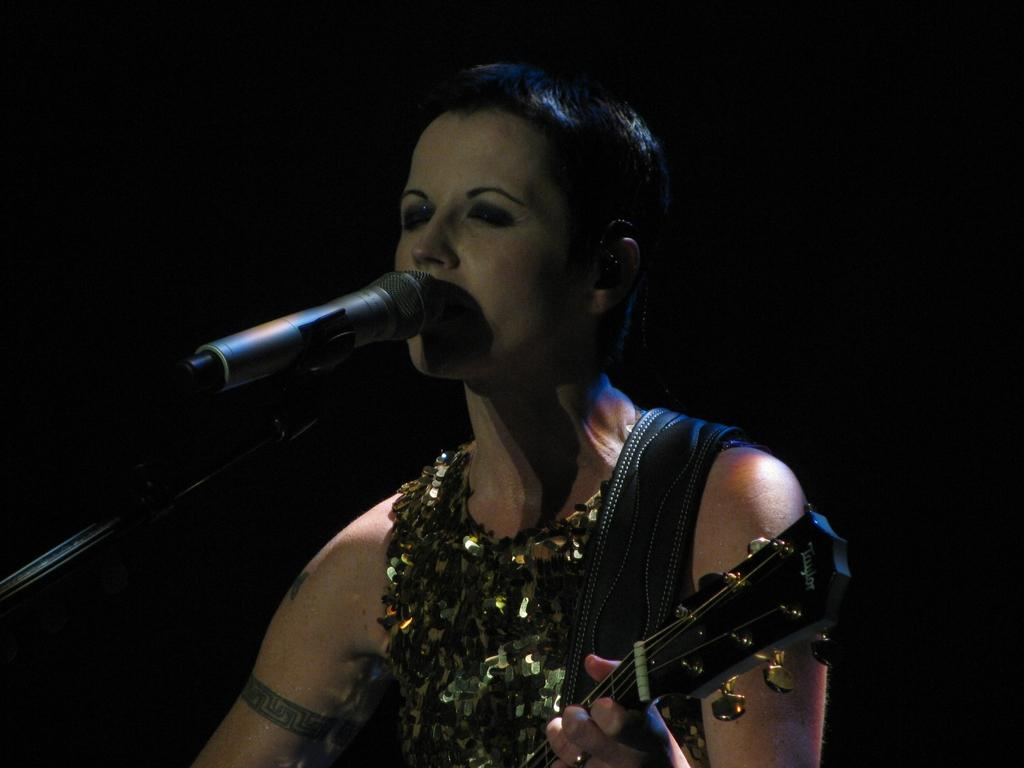Who is present in the image? There is a woman in the image. What is the woman doing in the image? The woman is standing in the image. What object is the woman holding in her hand? The woman is holding a guitar in her hand. What type of sand can be seen on the beach in the image? There is no beach or sand present in the image; it features a woman holding a guitar. How many boys are playing volleyball in the image? There are no boys or volleyball present in the image. 